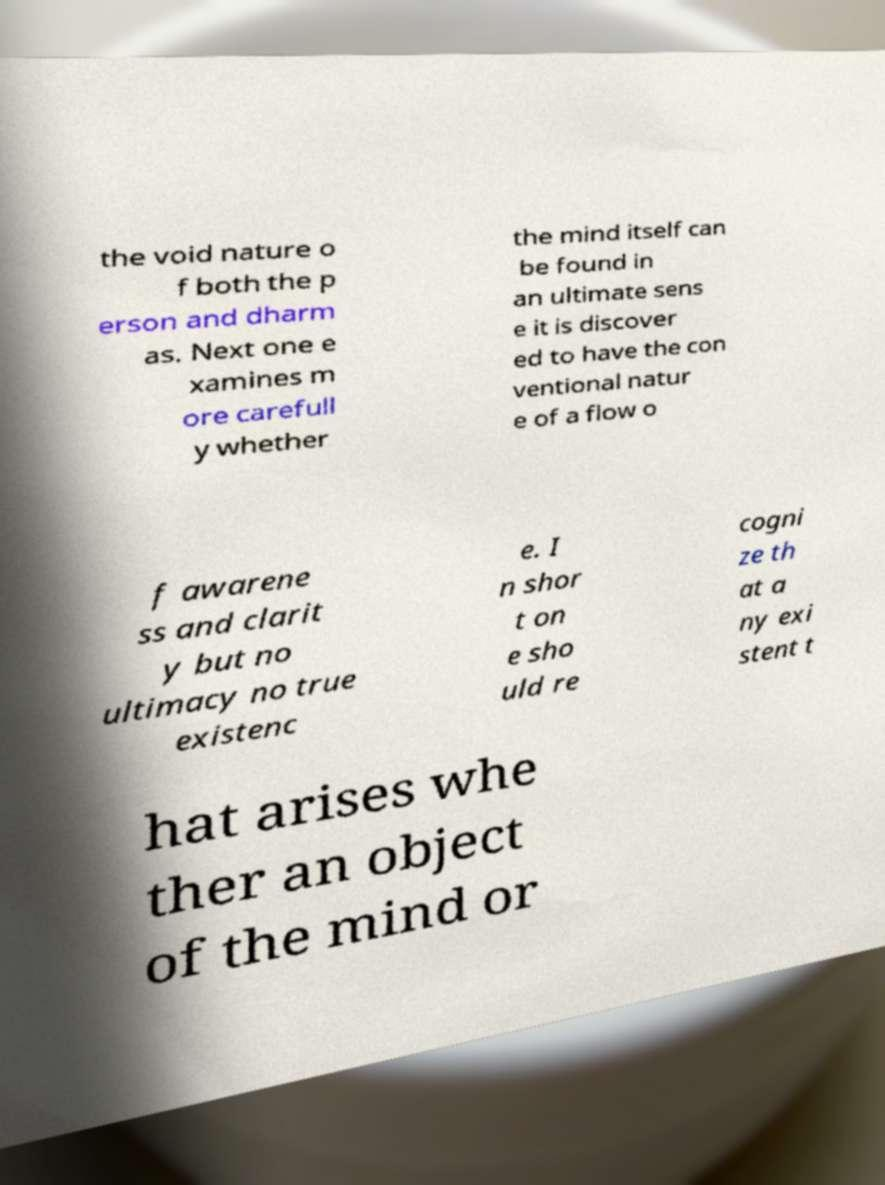Could you assist in decoding the text presented in this image and type it out clearly? the void nature o f both the p erson and dharm as. Next one e xamines m ore carefull y whether the mind itself can be found in an ultimate sens e it is discover ed to have the con ventional natur e of a flow o f awarene ss and clarit y but no ultimacy no true existenc e. I n shor t on e sho uld re cogni ze th at a ny exi stent t hat arises whe ther an object of the mind or 